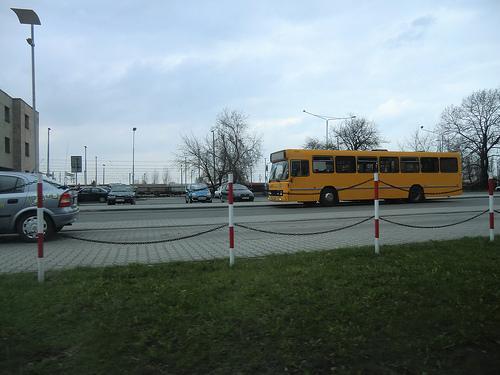How many buses are there?
Give a very brief answer. 1. 